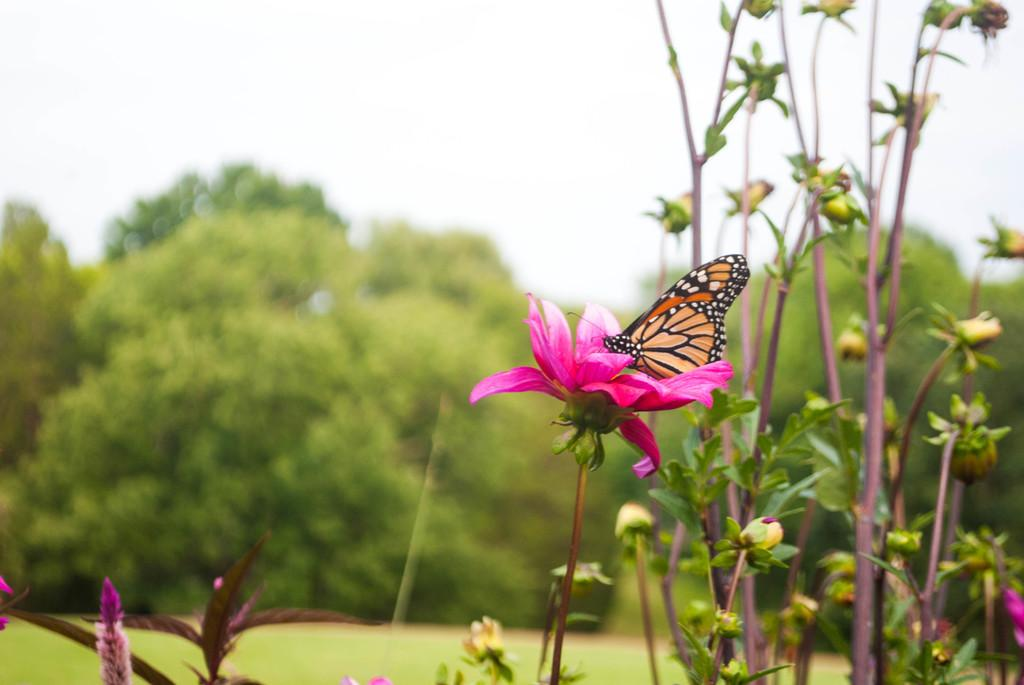What type of living organisms can be seen in the image? Plants and a butterfly can be seen in the image. Where is the butterfly located in the image? The butterfly is sitting on a flower in the image. What color is the flower the butterfly is sitting on? The flower is pink in color. What type of vegetation is present in the image besides the flower? There are green trees in the image. What is visible at the top of the image? The sky is visible at the top of the image. What type of committee is responsible for the maintenance of the plants in the image? There is no mention of a committee or any maintenance responsibility in the image. --- Facts: 1. There is a car in the image. 2. The car is red. 3. The car has four wheels. 4. There is a road in the image. 5. The road is paved. Absurd Topics: ocean, dance, microscope Conversation: What is the main subject of the image? The main subject of the image is a car. What color is the car? The car is red. How many wheels does the car have? The car has four wheels. What type of surface is visible in the image? There is a paved road in the image. Reasoning: Let's think step by step in order to produce the conversation. We start by identifying the main subject of the image, which is the car. Then, we describe the specific details of the car, such as its color and the number of wheels it has. Finally, we mention the presence of a paved road in the image, which provides context for the car's location. Absurd Question/Answer: Can you see any ocean waves in the image? No, there is no ocean or ocean waves present in the image. --- Facts: 1. There is a person in the image. 2. The person is wearing a hat. 3. The person is holding a book. 4. There is a chair in the image. 5. The chair is made of wood. Absurd Topics: parrot, volcano, guitar Conversation: Who or what is the main subject of the image? The main subject of the image is a person. What is the person wearing on their head? The person is wearing a hat. What object is the person holding in their hand? The person is holding a book. What type of furniture is present in the image? There is a wooden chair in the image. Reasoning: Let's think step by step in order to produce the conversation. We start by identifying the main subject of the image, which is the person. Then, we describe the specific details of the person' 